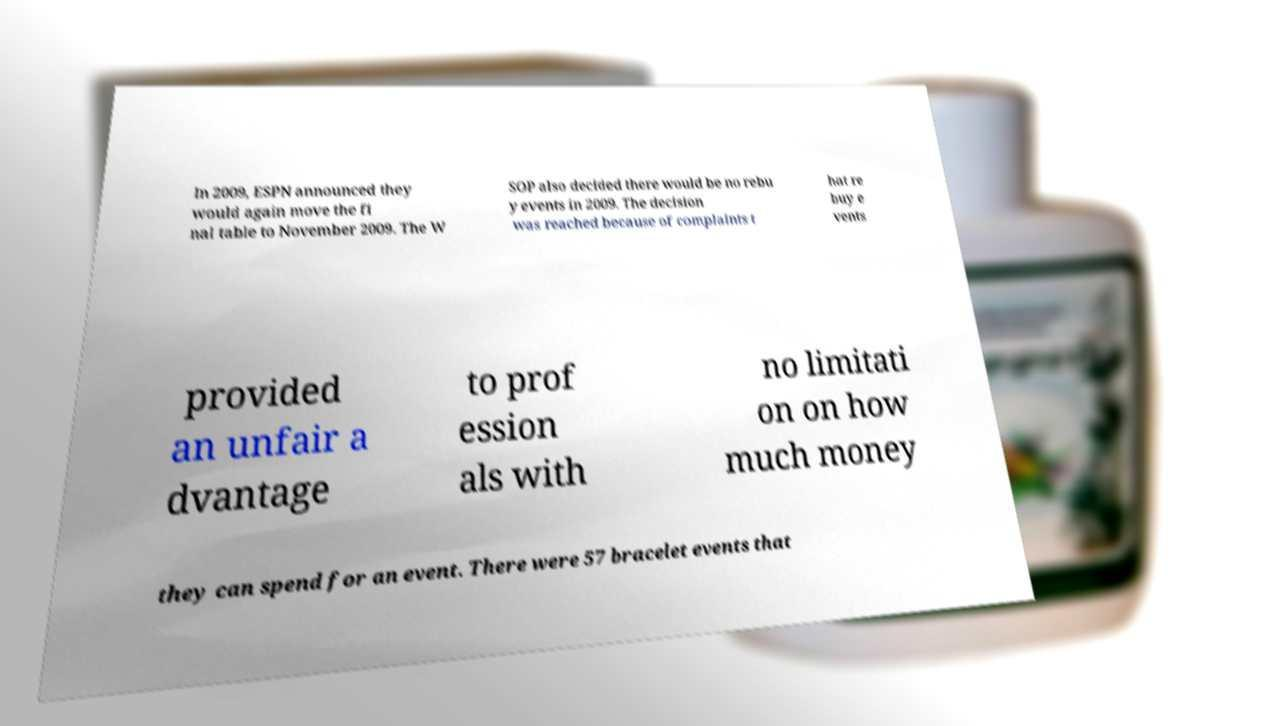Can you read and provide the text displayed in the image?This photo seems to have some interesting text. Can you extract and type it out for me? In 2009, ESPN announced they would again move the fi nal table to November 2009. The W SOP also decided there would be no rebu y events in 2009. The decision was reached because of complaints t hat re buy e vents provided an unfair a dvantage to prof ession als with no limitati on on how much money they can spend for an event. There were 57 bracelet events that 